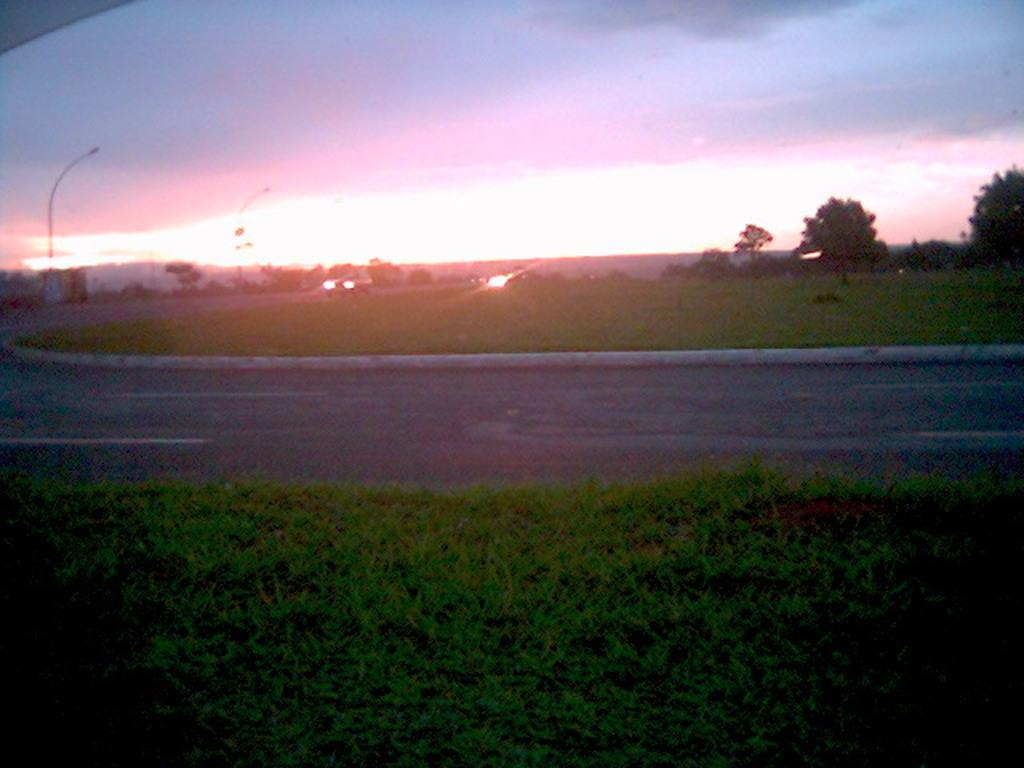What can be seen in the center of the image? There are vehicles on the road in the center of the image. What type of vegetation is present in the image? There are trees in the image, and grass is present at the bottom of the image. What can be seen in the background of the image? There are poles and the sky visible in the background of the image. What emotion is the grass displaying in the image? The grass does not display emotions; it is a plant and not capable of expressing emotions like anger. Is the image set during the winter season? The provided facts do not mention any specific season, so it cannot be determined if the image is set during the winter season. 